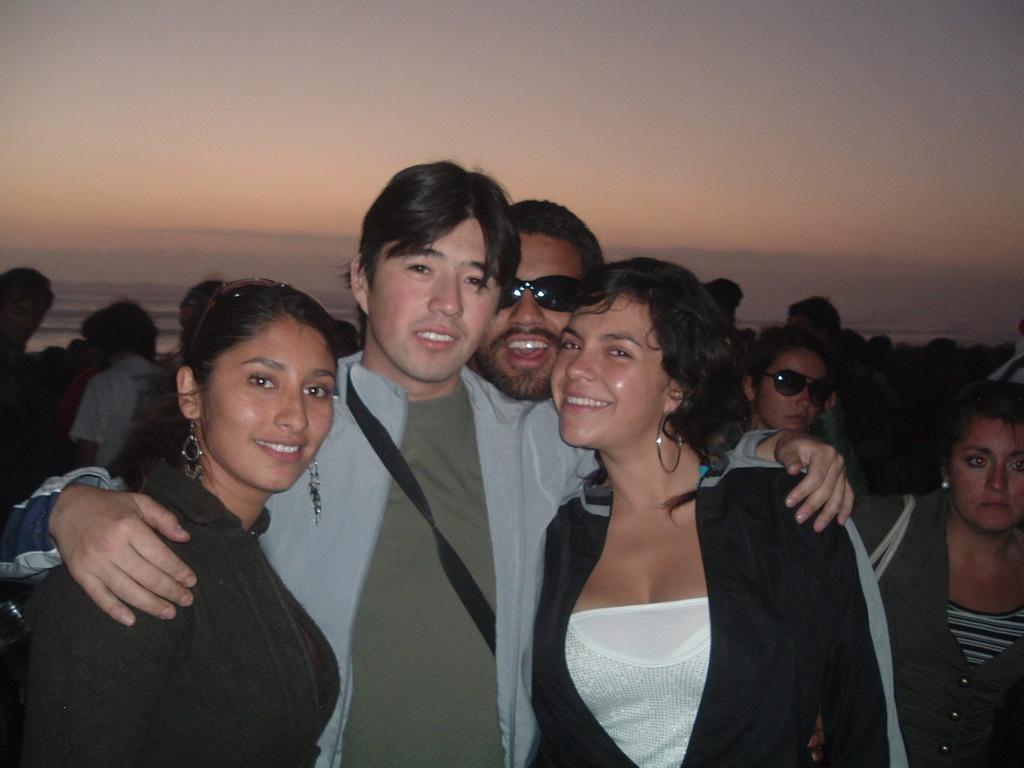Can you describe this image briefly? In this image, we can see many people and some are wearing glasses and one of them is wearing a bag. In the background, there is sky. 